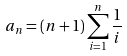<formula> <loc_0><loc_0><loc_500><loc_500>a _ { n } = ( n + 1 ) \sum _ { i = 1 } ^ { n } \frac { 1 } { i }</formula> 